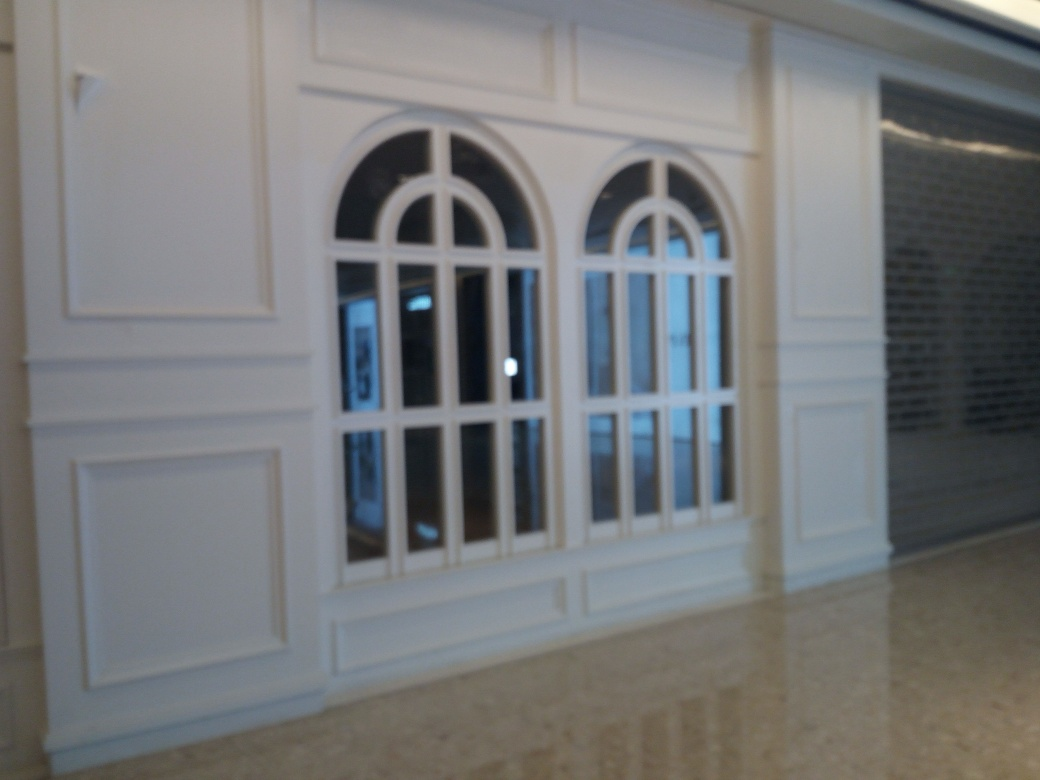What architectural style do the windows reflect? The windows suggest a classic architectural style, likely inspired by Georgian or Victorian designs, which is characterized by symmetry and the proportions of the arches. 